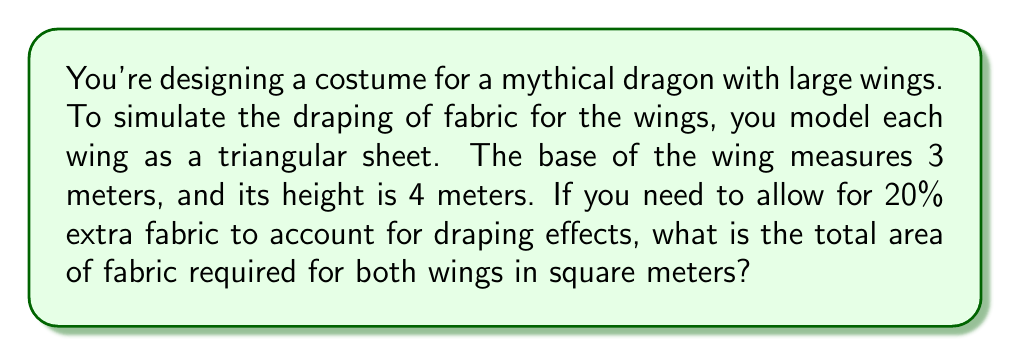Can you answer this question? Let's approach this step-by-step:

1) First, we need to calculate the area of one triangular wing:
   Area of a triangle = $\frac{1}{2} \times base \times height$
   $A = \frac{1}{2} \times 3 \times 4 = 6$ m²

2) Now, we need to account for both wings:
   Total area for both wings = $6 \times 2 = 12$ m²

3) We need to add 20% extra fabric for draping effects:
   20% of 12 m² = $12 \times 0.20 = 2.4$ m²

4) Total fabric required:
   $12 + 2.4 = 14.4$ m²

Therefore, the total area of fabric required for both wings, including the extra 20% for draping effects, is 14.4 square meters.
Answer: 14.4 m² 